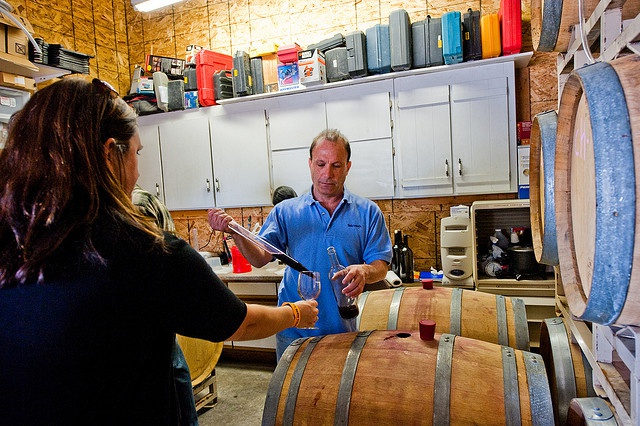Describe the objects in this image and their specific colors. I can see people in darkgray, black, maroon, and brown tones, people in darkgray, blue, maroon, and navy tones, suitcase in darkgray and gray tones, suitcase in darkgray, gray, black, and lightgray tones, and people in darkgray, black, tan, and olive tones in this image. 